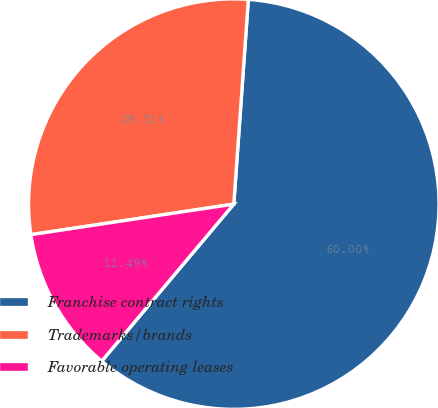Convert chart. <chart><loc_0><loc_0><loc_500><loc_500><pie_chart><fcel>Franchise contract rights<fcel>Trademarks/brands<fcel>Favorable operating leases<nl><fcel>60.0%<fcel>28.51%<fcel>11.49%<nl></chart> 